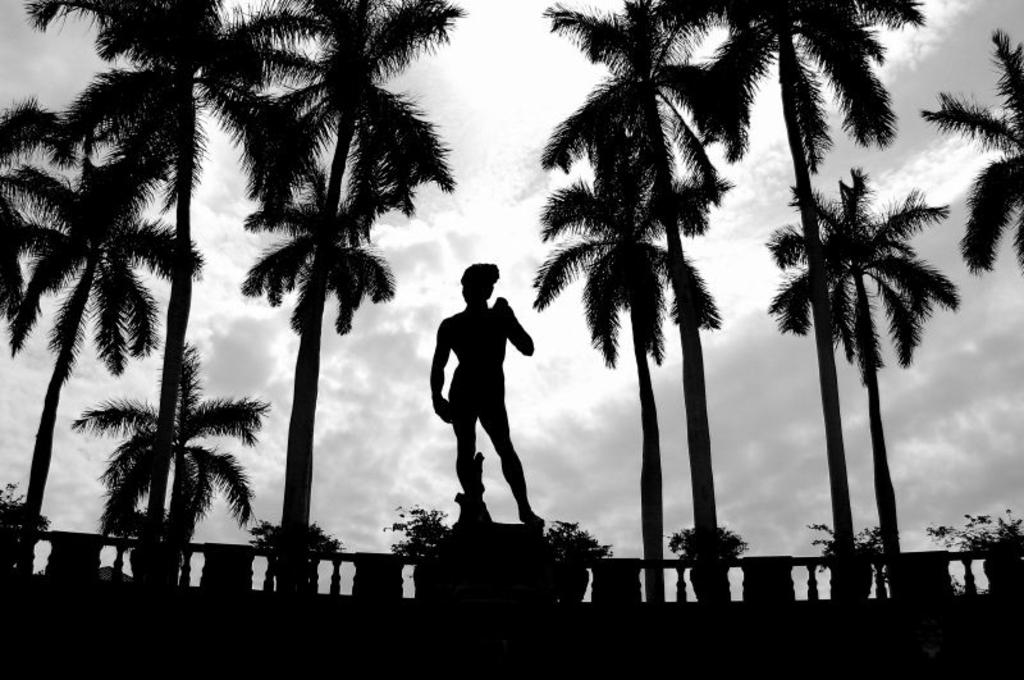What is the main subject of the image? There is a statue of a person standing in the image. What can be seen in the background of the image? There are many trees behind the statue. What color scheme is used in the image? The image is in black and white color. What time of day is it in the image, and who is the dad? The image is in black and white, so it is not possible to determine the time of day. Additionally, there is no information about a dad in the image. 